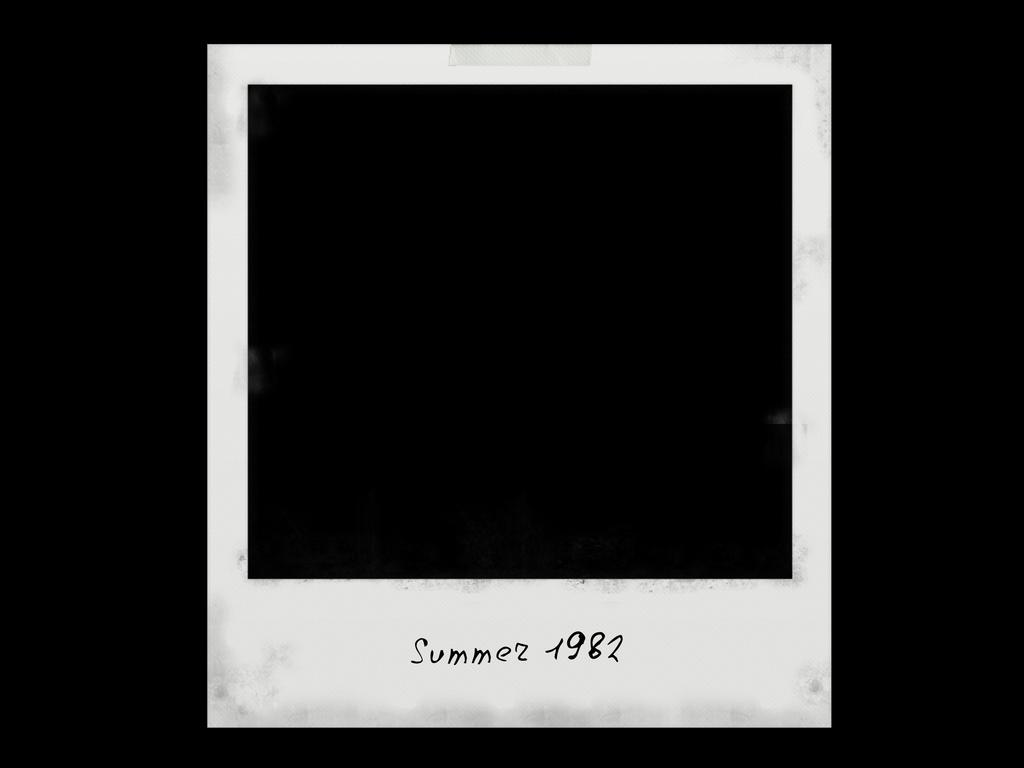<image>
Describe the image concisely. A Polaroid picture has Summer 1982 written in the white space. 